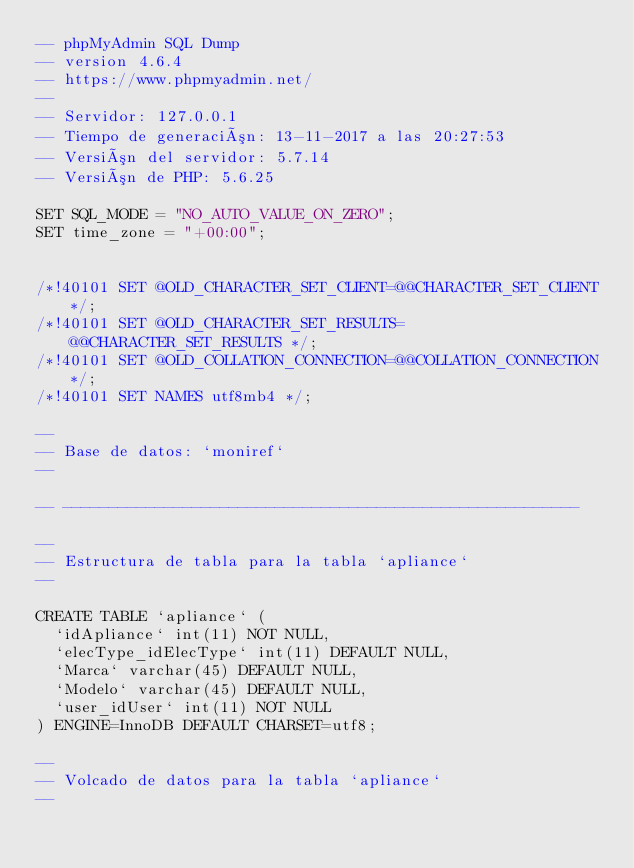Convert code to text. <code><loc_0><loc_0><loc_500><loc_500><_SQL_>-- phpMyAdmin SQL Dump
-- version 4.6.4
-- https://www.phpmyadmin.net/
--
-- Servidor: 127.0.0.1
-- Tiempo de generación: 13-11-2017 a las 20:27:53
-- Versión del servidor: 5.7.14
-- Versión de PHP: 5.6.25

SET SQL_MODE = "NO_AUTO_VALUE_ON_ZERO";
SET time_zone = "+00:00";


/*!40101 SET @OLD_CHARACTER_SET_CLIENT=@@CHARACTER_SET_CLIENT */;
/*!40101 SET @OLD_CHARACTER_SET_RESULTS=@@CHARACTER_SET_RESULTS */;
/*!40101 SET @OLD_COLLATION_CONNECTION=@@COLLATION_CONNECTION */;
/*!40101 SET NAMES utf8mb4 */;

--
-- Base de datos: `moniref`
--

-- --------------------------------------------------------

--
-- Estructura de tabla para la tabla `apliance`
--

CREATE TABLE `apliance` (
  `idApliance` int(11) NOT NULL,
  `elecType_idElecType` int(11) DEFAULT NULL,
  `Marca` varchar(45) DEFAULT NULL,
  `Modelo` varchar(45) DEFAULT NULL,
  `user_idUser` int(11) NOT NULL
) ENGINE=InnoDB DEFAULT CHARSET=utf8;

--
-- Volcado de datos para la tabla `apliance`
--
</code> 